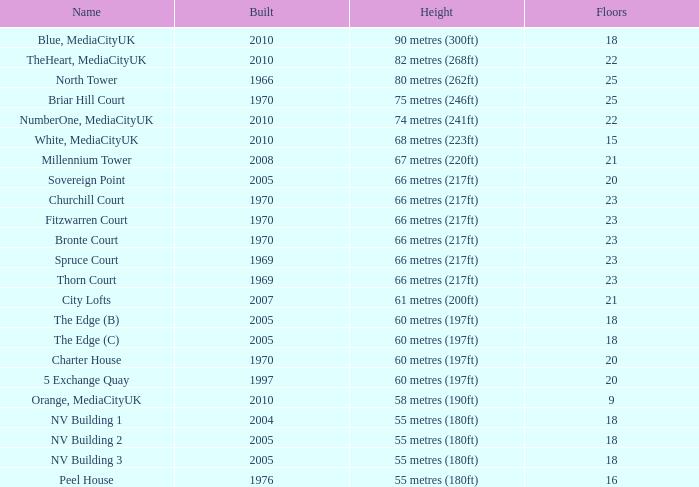What is the smallest number of floors for buildings erected after 1970, called nv building 3? 18.0. 